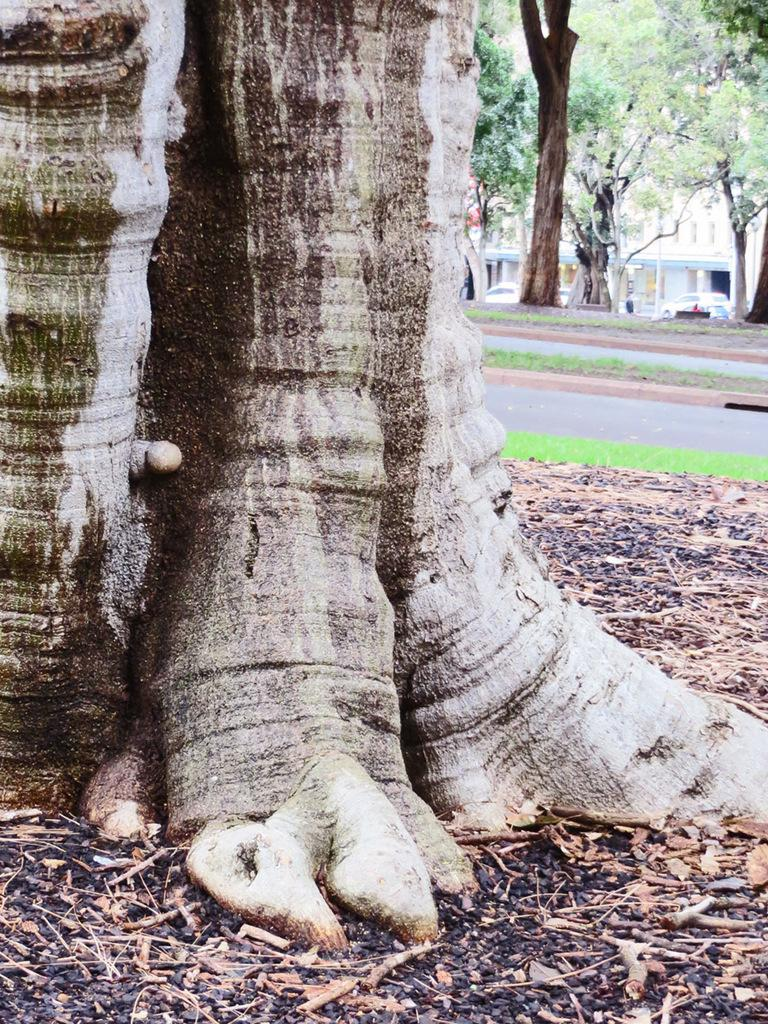What type of vegetation can be seen in the image? There are trees in the image. What else can be seen in the image besides trees? There is a road, cars, grass, and twigs visible in the image. What is the surface on which the cars are traveling? The cars are visible on the road in the image. What type of ground is present at the bottom of the image? There is grass at the bottom of the image. Can you see any jellyfish swimming in the grass in the image? There are no jellyfish present in the image, and jellyfish cannot swim in grass. What type of stew is being prepared on the road in the image? There is no stew being prepared in the image; the image features a road with cars on it. 